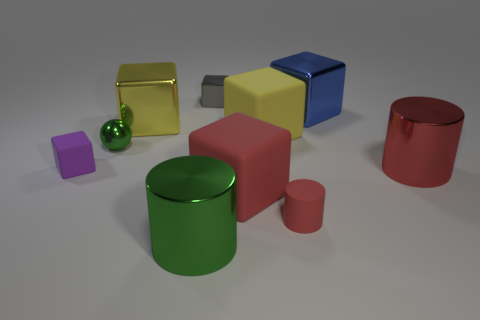Subtract all large yellow rubber cubes. How many cubes are left? 5 Subtract 3 blocks. How many blocks are left? 3 Subtract all gray cubes. How many cubes are left? 5 Subtract all yellow blocks. Subtract all red balls. How many blocks are left? 4 Subtract all spheres. How many objects are left? 9 Add 8 red shiny cylinders. How many red shiny cylinders exist? 9 Subtract 0 purple cylinders. How many objects are left? 10 Subtract all blue rubber cylinders. Subtract all tiny gray metallic blocks. How many objects are left? 9 Add 7 yellow objects. How many yellow objects are left? 9 